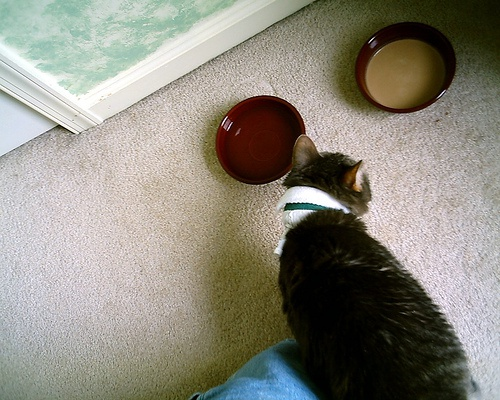Describe the objects in this image and their specific colors. I can see cat in lightblue, black, lightgray, gray, and darkgreen tones, bowl in lightblue, black, olive, and maroon tones, and bowl in lightblue, black, maroon, gray, and brown tones in this image. 